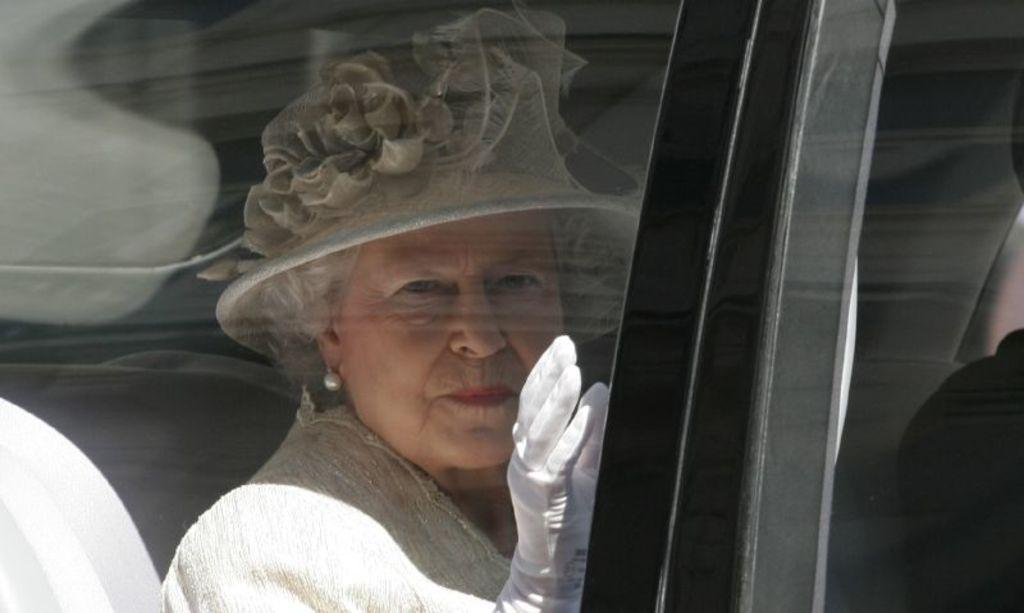What are the people in the image doing? The people in the image are sitting in a vehicle. Can you describe the lady's attire in the image? The lady is wearing a hat. How many shelves can be seen in the image? There are no shelves present in the image. What type of celebration is taking place in the image? There is no indication of a celebration or birthday in the image. 